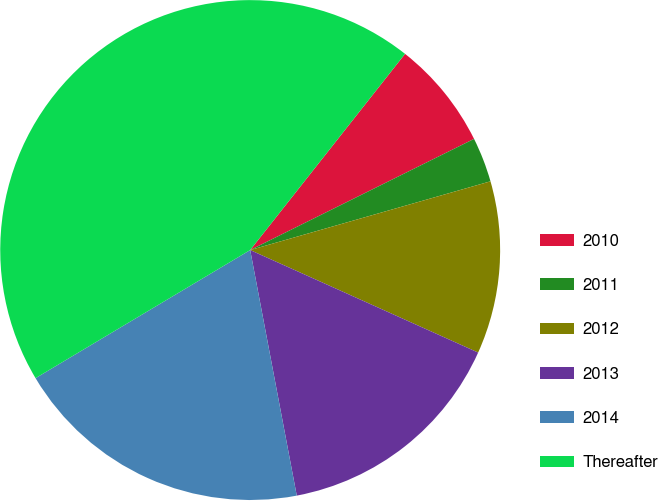Convert chart to OTSL. <chart><loc_0><loc_0><loc_500><loc_500><pie_chart><fcel>2010<fcel>2011<fcel>2012<fcel>2013<fcel>2014<fcel>Thereafter<nl><fcel>7.03%<fcel>2.9%<fcel>11.16%<fcel>15.29%<fcel>19.42%<fcel>44.2%<nl></chart> 